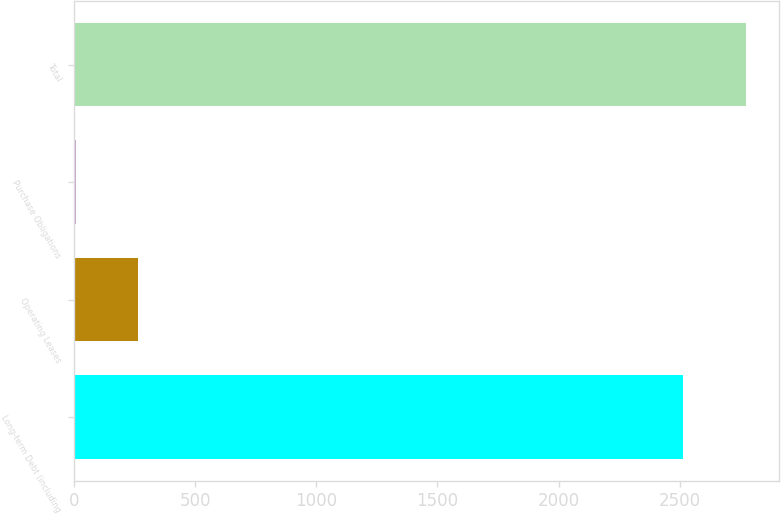<chart> <loc_0><loc_0><loc_500><loc_500><bar_chart><fcel>Long-term Debt (including<fcel>Operating Leases<fcel>Purchase Obligations<fcel>Total<nl><fcel>2514<fcel>265.3<fcel>6<fcel>2773.3<nl></chart> 